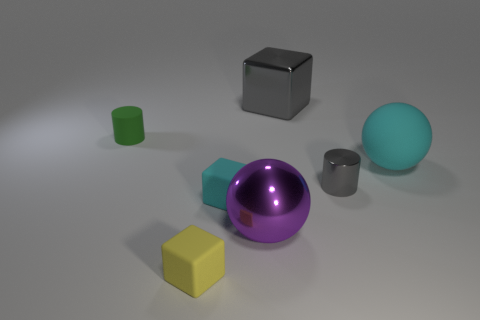Add 2 tiny yellow things. How many objects exist? 9 Subtract all cylinders. How many objects are left? 5 Add 5 shiny balls. How many shiny balls are left? 6 Add 6 yellow things. How many yellow things exist? 7 Subtract 0 gray spheres. How many objects are left? 7 Subtract all small gray cylinders. Subtract all cyan objects. How many objects are left? 4 